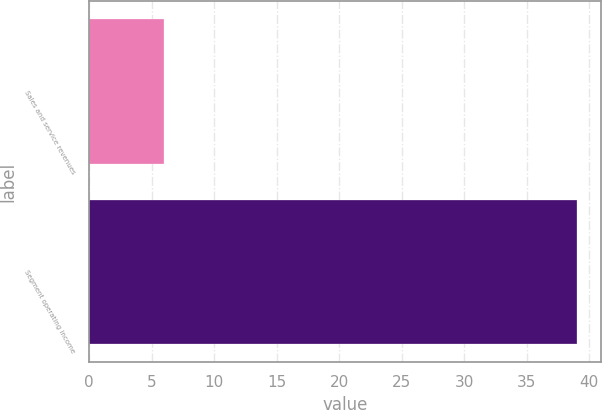<chart> <loc_0><loc_0><loc_500><loc_500><bar_chart><fcel>Sales and service revenues<fcel>Segment operating income<nl><fcel>6<fcel>39<nl></chart> 